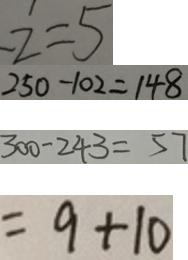Convert formula to latex. <formula><loc_0><loc_0><loc_500><loc_500>z = 5 
 2 5 0 - 1 0 2 = 1 4 8 
 3 0 0 - 2 4 3 = 5 7 
 = 9 + 1 0</formula> 